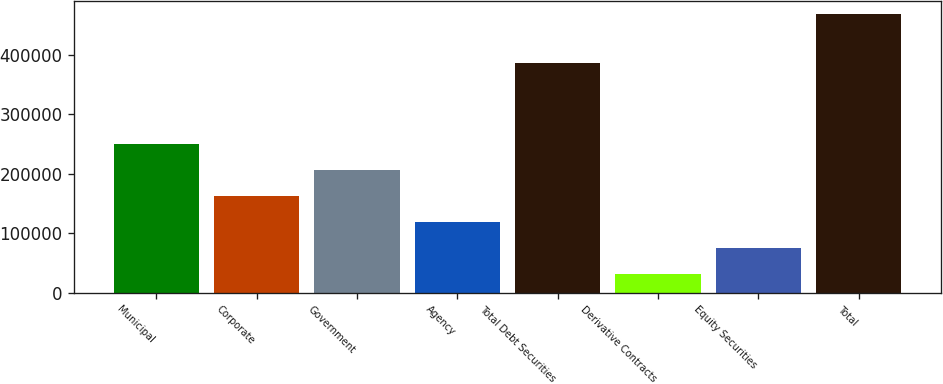Convert chart to OTSL. <chart><loc_0><loc_0><loc_500><loc_500><bar_chart><fcel>Municipal<fcel>Corporate<fcel>Government<fcel>Agency<fcel>Total Debt Securities<fcel>Derivative Contracts<fcel>Equity Securities<fcel>Total<nl><fcel>249182<fcel>161750<fcel>205466<fcel>118035<fcel>386538<fcel>30603<fcel>74318.8<fcel>467761<nl></chart> 